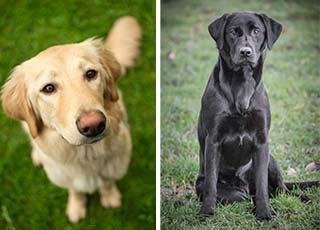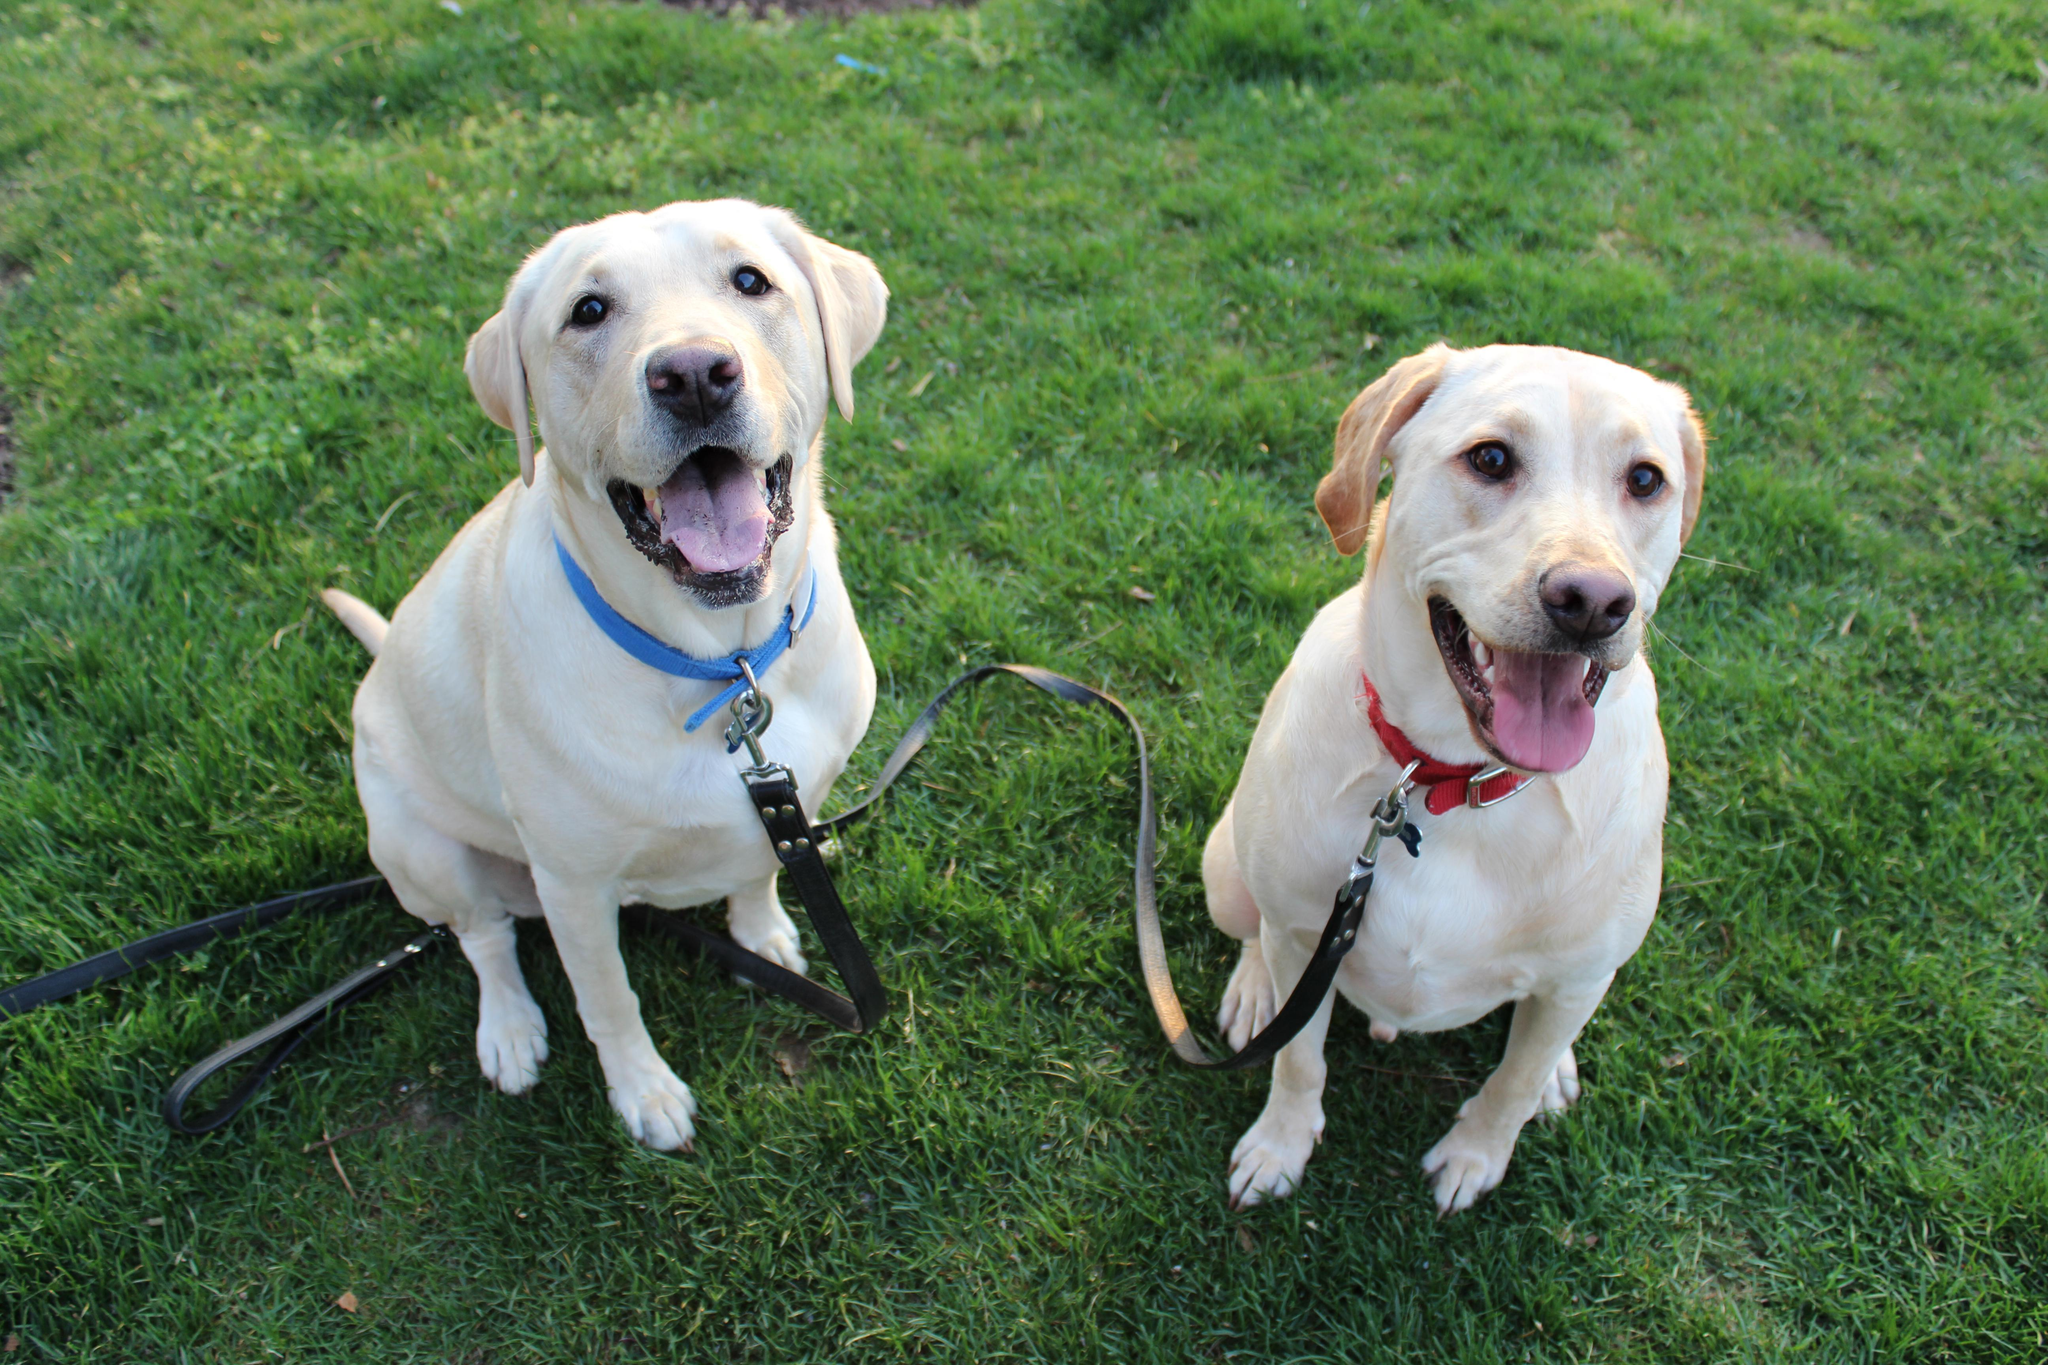The first image is the image on the left, the second image is the image on the right. Assess this claim about the two images: "There are four dogs in total.". Correct or not? Answer yes or no. Yes. The first image is the image on the left, the second image is the image on the right. Analyze the images presented: Is the assertion "The right image contains two dogs." valid? Answer yes or no. Yes. 